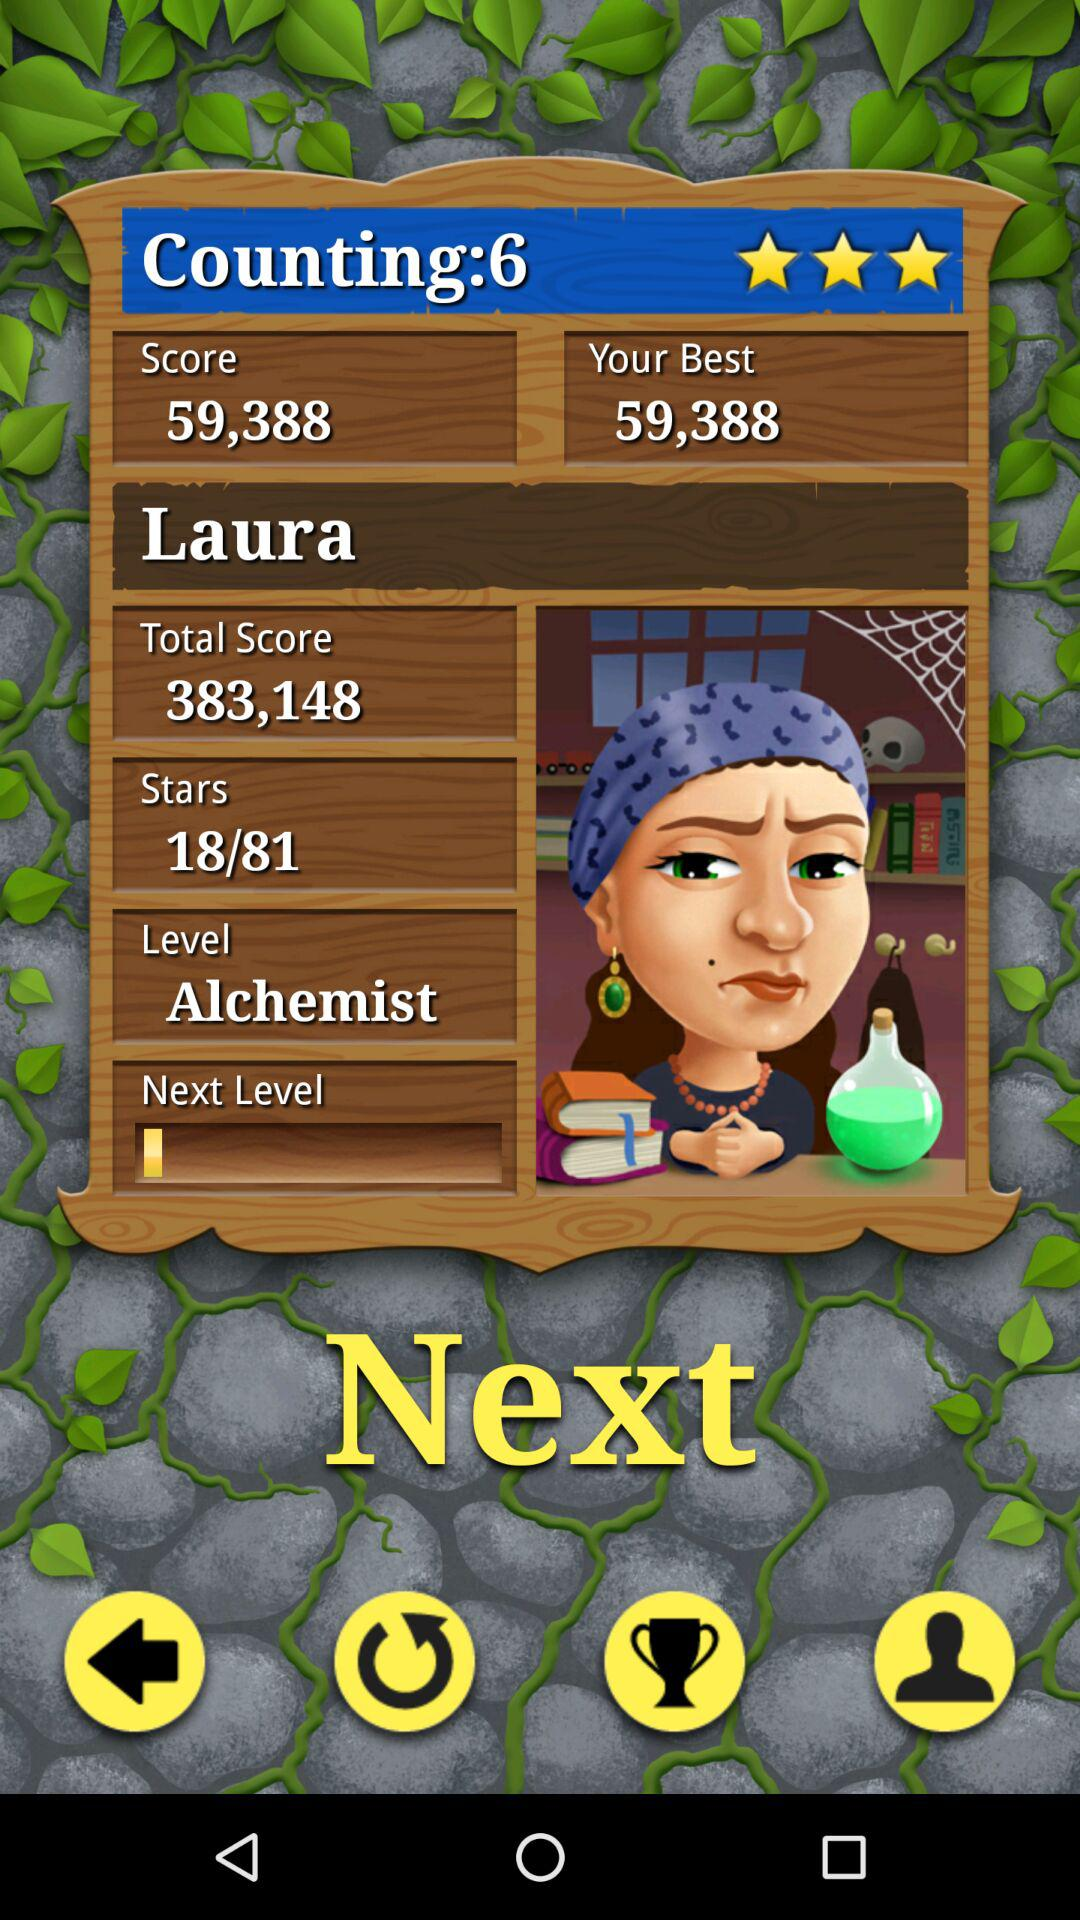What is the rating? The rating is 3 stars. 